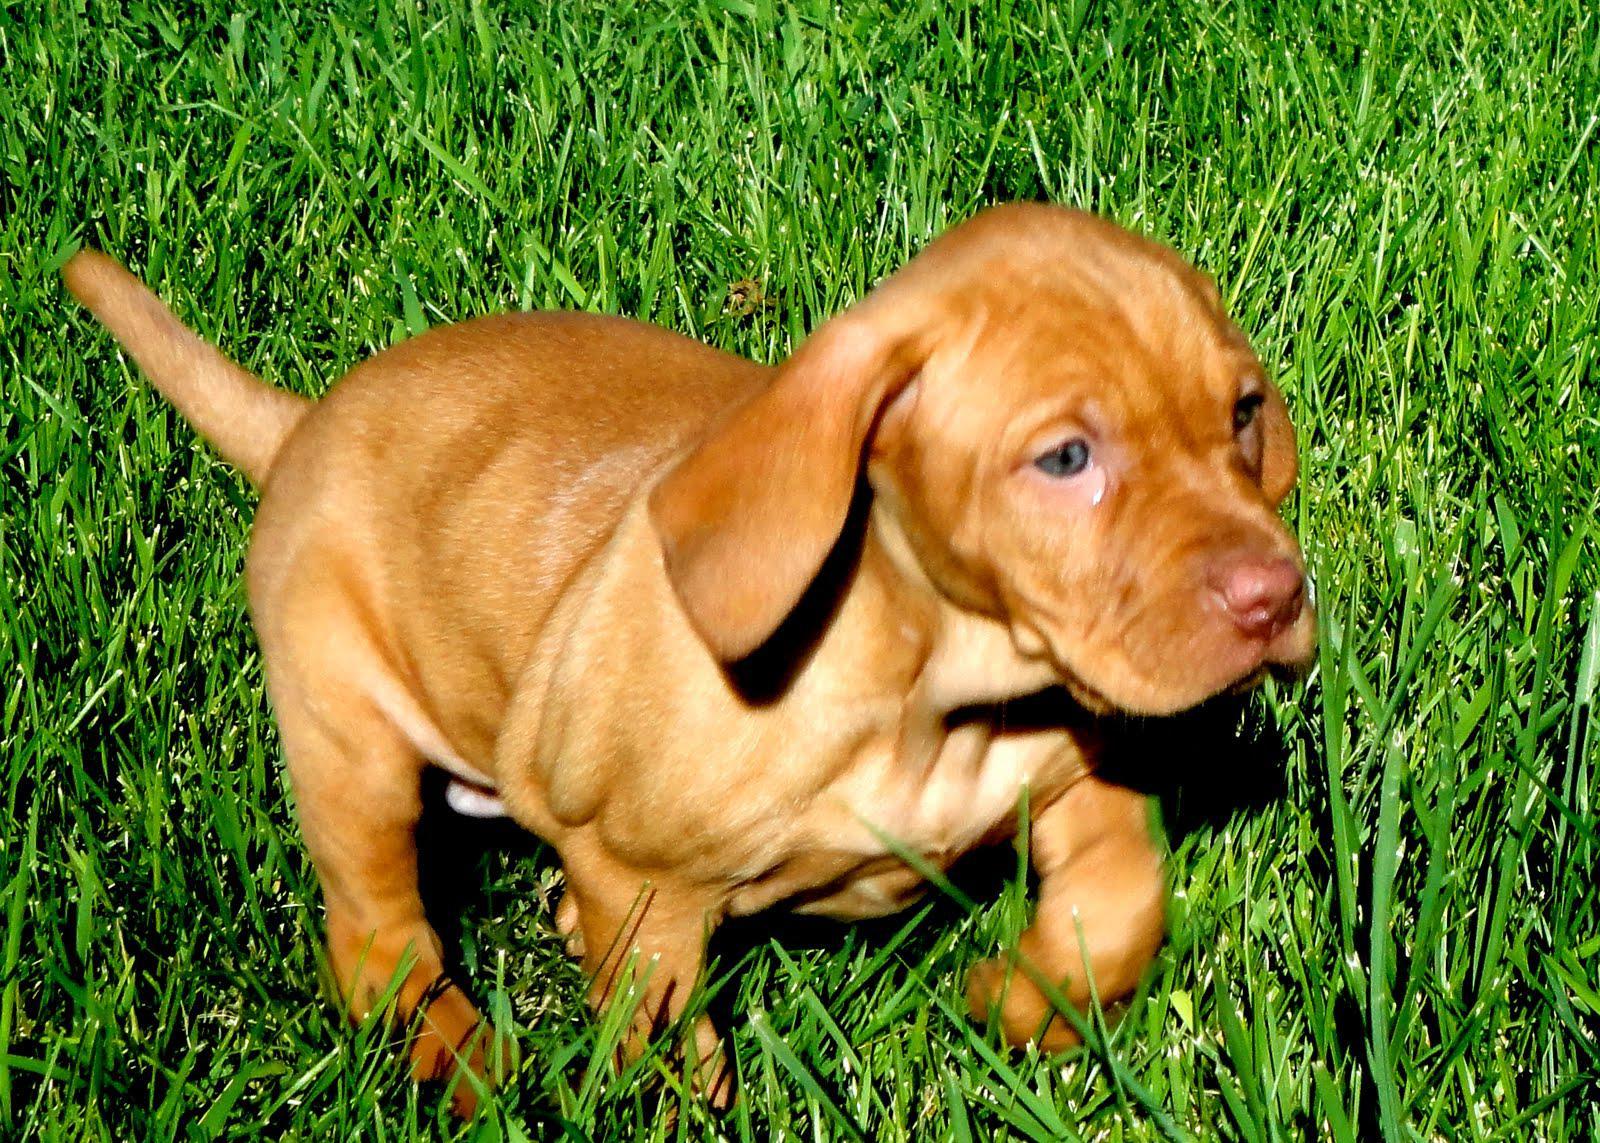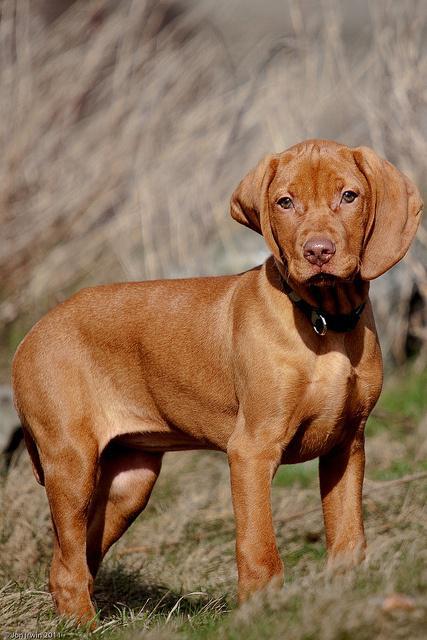The first image is the image on the left, the second image is the image on the right. Analyze the images presented: Is the assertion "Each image contains one red-orange dog, each dog has short hair and a closed mouth, and one image shows a dog with an upright head facing forward." valid? Answer yes or no. Yes. The first image is the image on the left, the second image is the image on the right. For the images displayed, is the sentence "There are two dogs." factually correct? Answer yes or no. Yes. 